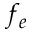Convert formula to latex. <formula><loc_0><loc_0><loc_500><loc_500>f _ { e }</formula> 